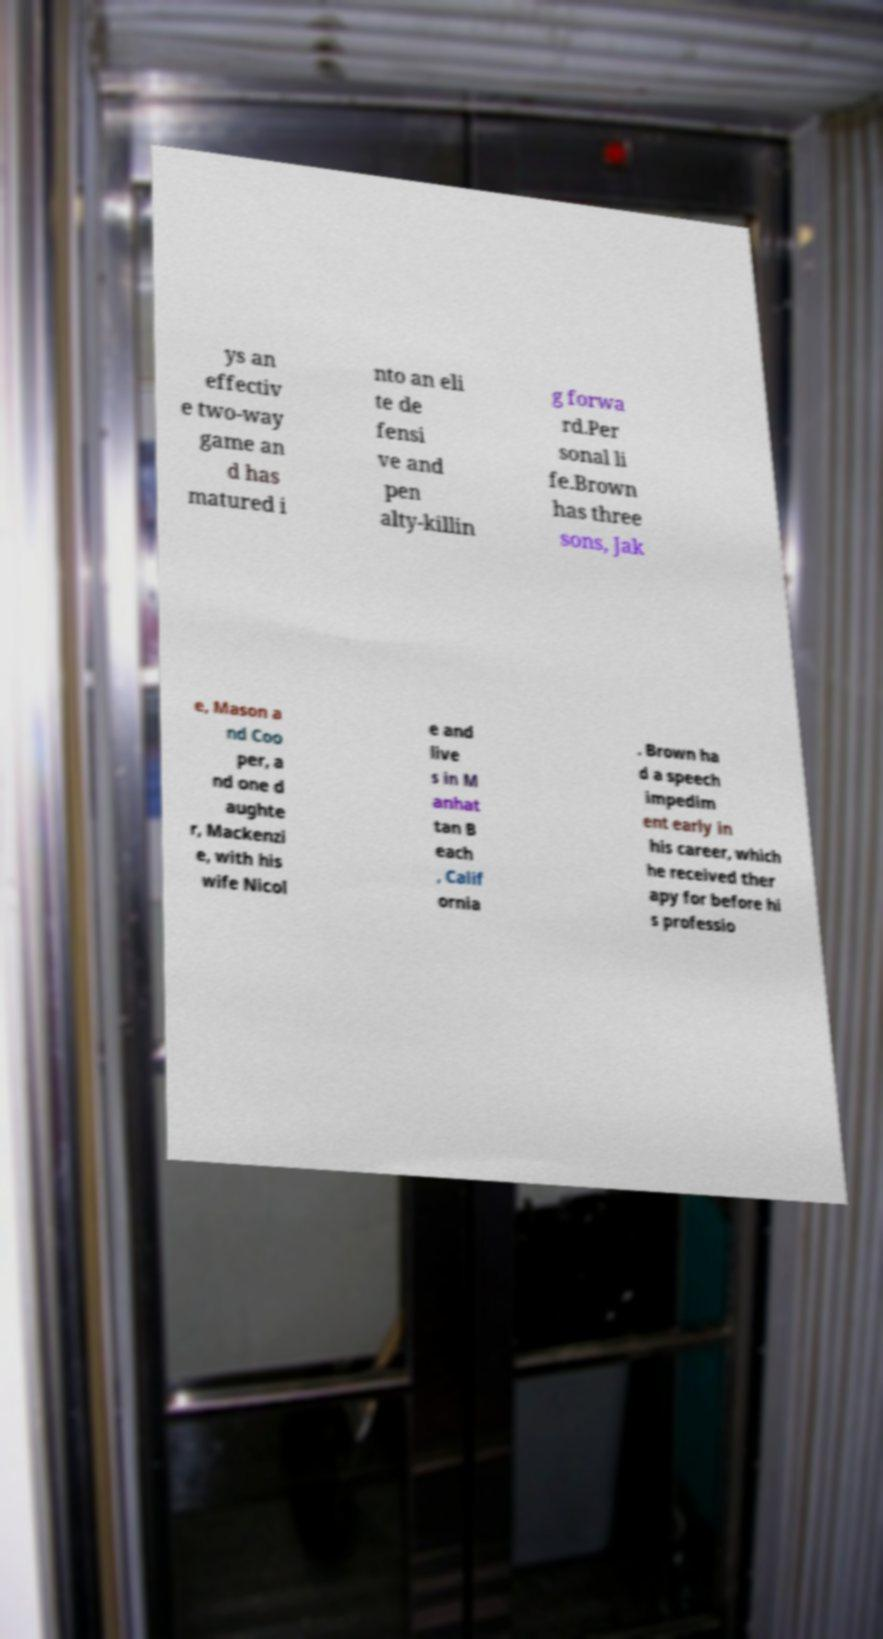Please identify and transcribe the text found in this image. ys an effectiv e two-way game an d has matured i nto an eli te de fensi ve and pen alty-killin g forwa rd.Per sonal li fe.Brown has three sons, Jak e, Mason a nd Coo per, a nd one d aughte r, Mackenzi e, with his wife Nicol e and live s in M anhat tan B each , Calif ornia . Brown ha d a speech impedim ent early in his career, which he received ther apy for before hi s professio 